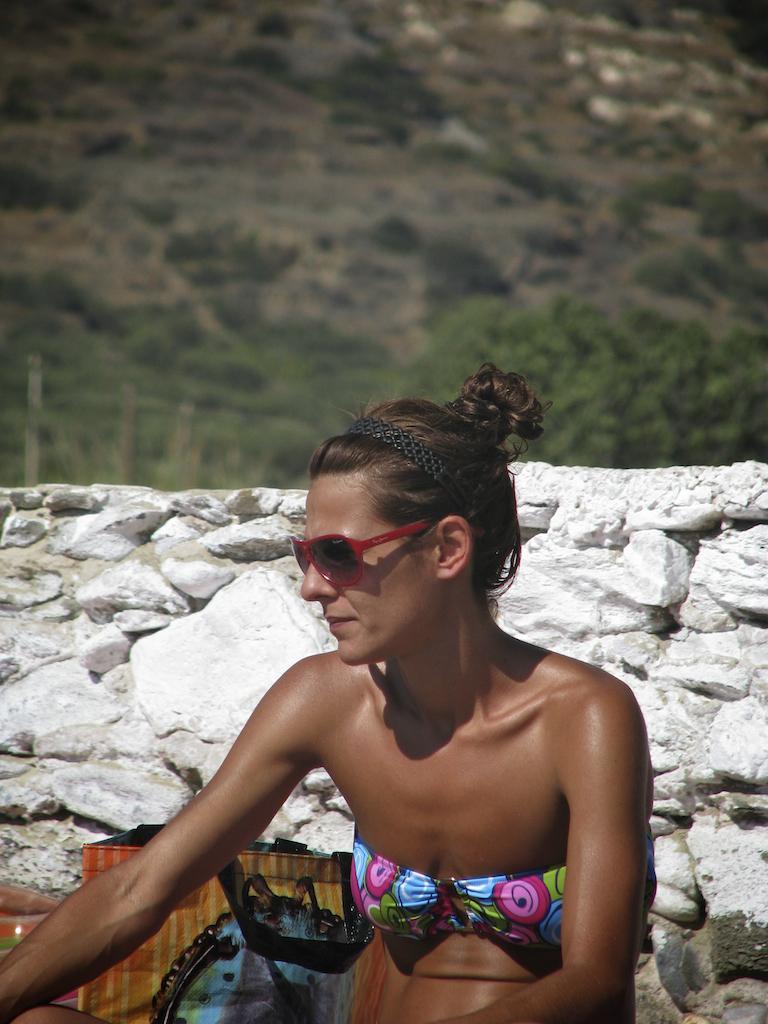Can you describe this image briefly? In this image I can see a lady behind her there is a bag, wall and mountain. 